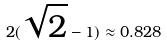<formula> <loc_0><loc_0><loc_500><loc_500>2 ( \sqrt { 2 } - 1 ) \approx 0 . 8 2 8</formula> 